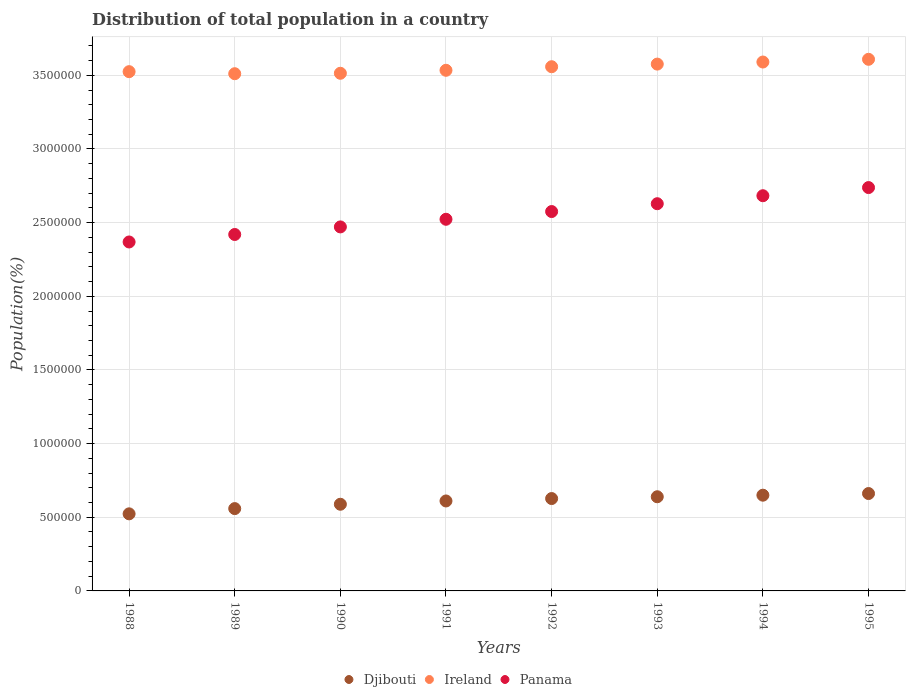How many different coloured dotlines are there?
Your response must be concise. 3. Is the number of dotlines equal to the number of legend labels?
Ensure brevity in your answer.  Yes. What is the population of in Panama in 1994?
Provide a short and direct response. 2.68e+06. Across all years, what is the maximum population of in Djibouti?
Provide a short and direct response. 6.61e+05. Across all years, what is the minimum population of in Djibouti?
Ensure brevity in your answer.  5.23e+05. What is the total population of in Panama in the graph?
Provide a succinct answer. 2.04e+07. What is the difference between the population of in Panama in 1989 and that in 1991?
Your response must be concise. -1.03e+05. What is the difference between the population of in Ireland in 1994 and the population of in Panama in 1992?
Provide a succinct answer. 1.02e+06. What is the average population of in Ireland per year?
Your answer should be compact. 3.55e+06. In the year 1993, what is the difference between the population of in Djibouti and population of in Ireland?
Make the answer very short. -2.94e+06. In how many years, is the population of in Panama greater than 1300000 %?
Make the answer very short. 8. What is the ratio of the population of in Panama in 1990 to that in 1993?
Offer a terse response. 0.94. What is the difference between the highest and the second highest population of in Ireland?
Your answer should be very brief. 1.85e+04. What is the difference between the highest and the lowest population of in Ireland?
Keep it short and to the point. 9.78e+04. In how many years, is the population of in Ireland greater than the average population of in Ireland taken over all years?
Your answer should be compact. 4. Does the population of in Djibouti monotonically increase over the years?
Make the answer very short. Yes. Is the population of in Ireland strictly greater than the population of in Panama over the years?
Provide a short and direct response. Yes. How many dotlines are there?
Your answer should be compact. 3. What is the difference between two consecutive major ticks on the Y-axis?
Ensure brevity in your answer.  5.00e+05. Are the values on the major ticks of Y-axis written in scientific E-notation?
Offer a very short reply. No. Does the graph contain any zero values?
Provide a succinct answer. No. How are the legend labels stacked?
Give a very brief answer. Horizontal. What is the title of the graph?
Give a very brief answer. Distribution of total population in a country. Does "Liechtenstein" appear as one of the legend labels in the graph?
Your response must be concise. No. What is the label or title of the X-axis?
Give a very brief answer. Years. What is the label or title of the Y-axis?
Keep it short and to the point. Population(%). What is the Population(%) of Djibouti in 1988?
Provide a succinct answer. 5.23e+05. What is the Population(%) of Ireland in 1988?
Provide a succinct answer. 3.52e+06. What is the Population(%) of Panama in 1988?
Your answer should be compact. 2.37e+06. What is the Population(%) in Djibouti in 1989?
Make the answer very short. 5.59e+05. What is the Population(%) in Ireland in 1989?
Give a very brief answer. 3.51e+06. What is the Population(%) of Panama in 1989?
Keep it short and to the point. 2.42e+06. What is the Population(%) of Djibouti in 1990?
Keep it short and to the point. 5.88e+05. What is the Population(%) in Ireland in 1990?
Ensure brevity in your answer.  3.51e+06. What is the Population(%) in Panama in 1990?
Give a very brief answer. 2.47e+06. What is the Population(%) of Djibouti in 1991?
Offer a terse response. 6.11e+05. What is the Population(%) of Ireland in 1991?
Your answer should be very brief. 3.53e+06. What is the Population(%) of Panama in 1991?
Your response must be concise. 2.52e+06. What is the Population(%) of Djibouti in 1992?
Provide a short and direct response. 6.27e+05. What is the Population(%) in Ireland in 1992?
Provide a short and direct response. 3.56e+06. What is the Population(%) in Panama in 1992?
Offer a very short reply. 2.58e+06. What is the Population(%) in Djibouti in 1993?
Keep it short and to the point. 6.39e+05. What is the Population(%) of Ireland in 1993?
Your answer should be compact. 3.58e+06. What is the Population(%) in Panama in 1993?
Make the answer very short. 2.63e+06. What is the Population(%) of Djibouti in 1994?
Offer a terse response. 6.50e+05. What is the Population(%) of Ireland in 1994?
Offer a terse response. 3.59e+06. What is the Population(%) of Panama in 1994?
Your response must be concise. 2.68e+06. What is the Population(%) of Djibouti in 1995?
Your response must be concise. 6.61e+05. What is the Population(%) of Ireland in 1995?
Provide a short and direct response. 3.61e+06. What is the Population(%) of Panama in 1995?
Keep it short and to the point. 2.74e+06. Across all years, what is the maximum Population(%) of Djibouti?
Your answer should be compact. 6.61e+05. Across all years, what is the maximum Population(%) of Ireland?
Offer a very short reply. 3.61e+06. Across all years, what is the maximum Population(%) of Panama?
Offer a very short reply. 2.74e+06. Across all years, what is the minimum Population(%) in Djibouti?
Provide a short and direct response. 5.23e+05. Across all years, what is the minimum Population(%) of Ireland?
Give a very brief answer. 3.51e+06. Across all years, what is the minimum Population(%) in Panama?
Provide a short and direct response. 2.37e+06. What is the total Population(%) in Djibouti in the graph?
Keep it short and to the point. 4.86e+06. What is the total Population(%) in Ireland in the graph?
Provide a short and direct response. 2.84e+07. What is the total Population(%) of Panama in the graph?
Keep it short and to the point. 2.04e+07. What is the difference between the Population(%) in Djibouti in 1988 and that in 1989?
Offer a terse response. -3.55e+04. What is the difference between the Population(%) in Ireland in 1988 and that in 1989?
Provide a short and direct response. 1.39e+04. What is the difference between the Population(%) in Panama in 1988 and that in 1989?
Your response must be concise. -5.08e+04. What is the difference between the Population(%) of Djibouti in 1988 and that in 1990?
Provide a succinct answer. -6.51e+04. What is the difference between the Population(%) in Ireland in 1988 and that in 1990?
Provide a short and direct response. 1.10e+04. What is the difference between the Population(%) of Panama in 1988 and that in 1990?
Offer a terse response. -1.02e+05. What is the difference between the Population(%) in Djibouti in 1988 and that in 1991?
Your answer should be very brief. -8.74e+04. What is the difference between the Population(%) in Ireland in 1988 and that in 1991?
Keep it short and to the point. -9286. What is the difference between the Population(%) in Panama in 1988 and that in 1991?
Your response must be concise. -1.54e+05. What is the difference between the Population(%) of Djibouti in 1988 and that in 1992?
Make the answer very short. -1.04e+05. What is the difference between the Population(%) of Ireland in 1988 and that in 1992?
Provide a succinct answer. -3.35e+04. What is the difference between the Population(%) of Panama in 1988 and that in 1992?
Keep it short and to the point. -2.07e+05. What is the difference between the Population(%) in Djibouti in 1988 and that in 1993?
Provide a succinct answer. -1.16e+05. What is the difference between the Population(%) in Ireland in 1988 and that in 1993?
Keep it short and to the point. -5.13e+04. What is the difference between the Population(%) of Panama in 1988 and that in 1993?
Ensure brevity in your answer.  -2.60e+05. What is the difference between the Population(%) in Djibouti in 1988 and that in 1994?
Offer a very short reply. -1.27e+05. What is the difference between the Population(%) of Ireland in 1988 and that in 1994?
Give a very brief answer. -6.54e+04. What is the difference between the Population(%) in Panama in 1988 and that in 1994?
Make the answer very short. -3.14e+05. What is the difference between the Population(%) of Djibouti in 1988 and that in 1995?
Provide a short and direct response. -1.38e+05. What is the difference between the Population(%) in Ireland in 1988 and that in 1995?
Your answer should be compact. -8.39e+04. What is the difference between the Population(%) in Panama in 1988 and that in 1995?
Your answer should be compact. -3.69e+05. What is the difference between the Population(%) of Djibouti in 1989 and that in 1990?
Offer a terse response. -2.95e+04. What is the difference between the Population(%) in Ireland in 1989 and that in 1990?
Give a very brief answer. -2965. What is the difference between the Population(%) in Panama in 1989 and that in 1990?
Keep it short and to the point. -5.14e+04. What is the difference between the Population(%) of Djibouti in 1989 and that in 1991?
Your response must be concise. -5.19e+04. What is the difference between the Population(%) in Ireland in 1989 and that in 1991?
Keep it short and to the point. -2.32e+04. What is the difference between the Population(%) of Panama in 1989 and that in 1991?
Offer a terse response. -1.03e+05. What is the difference between the Population(%) of Djibouti in 1989 and that in 1992?
Your response must be concise. -6.83e+04. What is the difference between the Population(%) of Ireland in 1989 and that in 1992?
Ensure brevity in your answer.  -4.74e+04. What is the difference between the Population(%) of Panama in 1989 and that in 1992?
Make the answer very short. -1.56e+05. What is the difference between the Population(%) of Djibouti in 1989 and that in 1993?
Your answer should be very brief. -8.04e+04. What is the difference between the Population(%) in Ireland in 1989 and that in 1993?
Offer a terse response. -6.53e+04. What is the difference between the Population(%) in Panama in 1989 and that in 1993?
Make the answer very short. -2.09e+05. What is the difference between the Population(%) of Djibouti in 1989 and that in 1994?
Make the answer very short. -9.11e+04. What is the difference between the Population(%) of Ireland in 1989 and that in 1994?
Offer a very short reply. -7.94e+04. What is the difference between the Population(%) of Panama in 1989 and that in 1994?
Ensure brevity in your answer.  -2.63e+05. What is the difference between the Population(%) of Djibouti in 1989 and that in 1995?
Your answer should be very brief. -1.02e+05. What is the difference between the Population(%) in Ireland in 1989 and that in 1995?
Offer a very short reply. -9.78e+04. What is the difference between the Population(%) in Panama in 1989 and that in 1995?
Your answer should be compact. -3.19e+05. What is the difference between the Population(%) of Djibouti in 1990 and that in 1991?
Make the answer very short. -2.23e+04. What is the difference between the Population(%) of Ireland in 1990 and that in 1991?
Your response must be concise. -2.03e+04. What is the difference between the Population(%) in Panama in 1990 and that in 1991?
Your answer should be compact. -5.19e+04. What is the difference between the Population(%) of Djibouti in 1990 and that in 1992?
Keep it short and to the point. -3.87e+04. What is the difference between the Population(%) of Ireland in 1990 and that in 1992?
Provide a short and direct response. -4.45e+04. What is the difference between the Population(%) of Panama in 1990 and that in 1992?
Provide a short and direct response. -1.04e+05. What is the difference between the Population(%) in Djibouti in 1990 and that in 1993?
Make the answer very short. -5.09e+04. What is the difference between the Population(%) of Ireland in 1990 and that in 1993?
Provide a short and direct response. -6.23e+04. What is the difference between the Population(%) in Panama in 1990 and that in 1993?
Provide a short and direct response. -1.58e+05. What is the difference between the Population(%) in Djibouti in 1990 and that in 1994?
Offer a terse response. -6.15e+04. What is the difference between the Population(%) in Ireland in 1990 and that in 1994?
Keep it short and to the point. -7.64e+04. What is the difference between the Population(%) of Panama in 1990 and that in 1994?
Your response must be concise. -2.12e+05. What is the difference between the Population(%) of Djibouti in 1990 and that in 1995?
Offer a terse response. -7.27e+04. What is the difference between the Population(%) in Ireland in 1990 and that in 1995?
Your answer should be compact. -9.49e+04. What is the difference between the Population(%) in Panama in 1990 and that in 1995?
Your response must be concise. -2.67e+05. What is the difference between the Population(%) in Djibouti in 1991 and that in 1992?
Provide a short and direct response. -1.64e+04. What is the difference between the Population(%) of Ireland in 1991 and that in 1992?
Give a very brief answer. -2.42e+04. What is the difference between the Population(%) in Panama in 1991 and that in 1992?
Provide a succinct answer. -5.24e+04. What is the difference between the Population(%) in Djibouti in 1991 and that in 1993?
Your answer should be compact. -2.85e+04. What is the difference between the Population(%) of Ireland in 1991 and that in 1993?
Ensure brevity in your answer.  -4.20e+04. What is the difference between the Population(%) in Panama in 1991 and that in 1993?
Provide a succinct answer. -1.06e+05. What is the difference between the Population(%) in Djibouti in 1991 and that in 1994?
Your answer should be very brief. -3.92e+04. What is the difference between the Population(%) of Ireland in 1991 and that in 1994?
Give a very brief answer. -5.62e+04. What is the difference between the Population(%) of Panama in 1991 and that in 1994?
Offer a very short reply. -1.60e+05. What is the difference between the Population(%) in Djibouti in 1991 and that in 1995?
Keep it short and to the point. -5.04e+04. What is the difference between the Population(%) of Ireland in 1991 and that in 1995?
Your answer should be very brief. -7.46e+04. What is the difference between the Population(%) in Panama in 1991 and that in 1995?
Offer a terse response. -2.15e+05. What is the difference between the Population(%) in Djibouti in 1992 and that in 1993?
Provide a short and direct response. -1.22e+04. What is the difference between the Population(%) of Ireland in 1992 and that in 1993?
Give a very brief answer. -1.78e+04. What is the difference between the Population(%) of Panama in 1992 and that in 1993?
Your answer should be very brief. -5.32e+04. What is the difference between the Population(%) of Djibouti in 1992 and that in 1994?
Your response must be concise. -2.28e+04. What is the difference between the Population(%) of Ireland in 1992 and that in 1994?
Offer a very short reply. -3.20e+04. What is the difference between the Population(%) of Panama in 1992 and that in 1994?
Give a very brief answer. -1.07e+05. What is the difference between the Population(%) in Djibouti in 1992 and that in 1995?
Keep it short and to the point. -3.40e+04. What is the difference between the Population(%) of Ireland in 1992 and that in 1995?
Your answer should be very brief. -5.04e+04. What is the difference between the Population(%) in Panama in 1992 and that in 1995?
Ensure brevity in your answer.  -1.63e+05. What is the difference between the Population(%) of Djibouti in 1993 and that in 1994?
Provide a succinct answer. -1.07e+04. What is the difference between the Population(%) of Ireland in 1993 and that in 1994?
Provide a succinct answer. -1.41e+04. What is the difference between the Population(%) of Panama in 1993 and that in 1994?
Your response must be concise. -5.42e+04. What is the difference between the Population(%) of Djibouti in 1993 and that in 1995?
Offer a terse response. -2.19e+04. What is the difference between the Population(%) of Ireland in 1993 and that in 1995?
Provide a short and direct response. -3.26e+04. What is the difference between the Population(%) of Panama in 1993 and that in 1995?
Your answer should be compact. -1.10e+05. What is the difference between the Population(%) of Djibouti in 1994 and that in 1995?
Make the answer very short. -1.12e+04. What is the difference between the Population(%) of Ireland in 1994 and that in 1995?
Offer a very short reply. -1.85e+04. What is the difference between the Population(%) in Panama in 1994 and that in 1995?
Give a very brief answer. -5.54e+04. What is the difference between the Population(%) in Djibouti in 1988 and the Population(%) in Ireland in 1989?
Your response must be concise. -2.99e+06. What is the difference between the Population(%) in Djibouti in 1988 and the Population(%) in Panama in 1989?
Your response must be concise. -1.90e+06. What is the difference between the Population(%) of Ireland in 1988 and the Population(%) of Panama in 1989?
Give a very brief answer. 1.11e+06. What is the difference between the Population(%) of Djibouti in 1988 and the Population(%) of Ireland in 1990?
Give a very brief answer. -2.99e+06. What is the difference between the Population(%) in Djibouti in 1988 and the Population(%) in Panama in 1990?
Your response must be concise. -1.95e+06. What is the difference between the Population(%) of Ireland in 1988 and the Population(%) of Panama in 1990?
Provide a succinct answer. 1.05e+06. What is the difference between the Population(%) of Djibouti in 1988 and the Population(%) of Ireland in 1991?
Your response must be concise. -3.01e+06. What is the difference between the Population(%) of Djibouti in 1988 and the Population(%) of Panama in 1991?
Keep it short and to the point. -2.00e+06. What is the difference between the Population(%) of Ireland in 1988 and the Population(%) of Panama in 1991?
Provide a succinct answer. 1.00e+06. What is the difference between the Population(%) in Djibouti in 1988 and the Population(%) in Ireland in 1992?
Keep it short and to the point. -3.04e+06. What is the difference between the Population(%) in Djibouti in 1988 and the Population(%) in Panama in 1992?
Your answer should be very brief. -2.05e+06. What is the difference between the Population(%) of Ireland in 1988 and the Population(%) of Panama in 1992?
Your response must be concise. 9.50e+05. What is the difference between the Population(%) of Djibouti in 1988 and the Population(%) of Ireland in 1993?
Provide a succinct answer. -3.05e+06. What is the difference between the Population(%) of Djibouti in 1988 and the Population(%) of Panama in 1993?
Provide a short and direct response. -2.11e+06. What is the difference between the Population(%) in Ireland in 1988 and the Population(%) in Panama in 1993?
Offer a very short reply. 8.96e+05. What is the difference between the Population(%) of Djibouti in 1988 and the Population(%) of Ireland in 1994?
Provide a succinct answer. -3.07e+06. What is the difference between the Population(%) in Djibouti in 1988 and the Population(%) in Panama in 1994?
Provide a succinct answer. -2.16e+06. What is the difference between the Population(%) in Ireland in 1988 and the Population(%) in Panama in 1994?
Make the answer very short. 8.42e+05. What is the difference between the Population(%) in Djibouti in 1988 and the Population(%) in Ireland in 1995?
Your answer should be very brief. -3.09e+06. What is the difference between the Population(%) of Djibouti in 1988 and the Population(%) of Panama in 1995?
Make the answer very short. -2.21e+06. What is the difference between the Population(%) of Ireland in 1988 and the Population(%) of Panama in 1995?
Your response must be concise. 7.87e+05. What is the difference between the Population(%) of Djibouti in 1989 and the Population(%) of Ireland in 1990?
Provide a short and direct response. -2.96e+06. What is the difference between the Population(%) in Djibouti in 1989 and the Population(%) in Panama in 1990?
Make the answer very short. -1.91e+06. What is the difference between the Population(%) in Ireland in 1989 and the Population(%) in Panama in 1990?
Offer a terse response. 1.04e+06. What is the difference between the Population(%) of Djibouti in 1989 and the Population(%) of Ireland in 1991?
Provide a succinct answer. -2.98e+06. What is the difference between the Population(%) of Djibouti in 1989 and the Population(%) of Panama in 1991?
Your answer should be very brief. -1.96e+06. What is the difference between the Population(%) in Ireland in 1989 and the Population(%) in Panama in 1991?
Give a very brief answer. 9.88e+05. What is the difference between the Population(%) in Djibouti in 1989 and the Population(%) in Ireland in 1992?
Your response must be concise. -3.00e+06. What is the difference between the Population(%) in Djibouti in 1989 and the Population(%) in Panama in 1992?
Provide a short and direct response. -2.02e+06. What is the difference between the Population(%) of Ireland in 1989 and the Population(%) of Panama in 1992?
Give a very brief answer. 9.36e+05. What is the difference between the Population(%) in Djibouti in 1989 and the Population(%) in Ireland in 1993?
Your answer should be very brief. -3.02e+06. What is the difference between the Population(%) in Djibouti in 1989 and the Population(%) in Panama in 1993?
Provide a short and direct response. -2.07e+06. What is the difference between the Population(%) of Ireland in 1989 and the Population(%) of Panama in 1993?
Keep it short and to the point. 8.82e+05. What is the difference between the Population(%) of Djibouti in 1989 and the Population(%) of Ireland in 1994?
Offer a very short reply. -3.03e+06. What is the difference between the Population(%) in Djibouti in 1989 and the Population(%) in Panama in 1994?
Give a very brief answer. -2.12e+06. What is the difference between the Population(%) in Ireland in 1989 and the Population(%) in Panama in 1994?
Make the answer very short. 8.28e+05. What is the difference between the Population(%) of Djibouti in 1989 and the Population(%) of Ireland in 1995?
Provide a succinct answer. -3.05e+06. What is the difference between the Population(%) of Djibouti in 1989 and the Population(%) of Panama in 1995?
Provide a short and direct response. -2.18e+06. What is the difference between the Population(%) of Ireland in 1989 and the Population(%) of Panama in 1995?
Keep it short and to the point. 7.73e+05. What is the difference between the Population(%) in Djibouti in 1990 and the Population(%) in Ireland in 1991?
Your response must be concise. -2.95e+06. What is the difference between the Population(%) in Djibouti in 1990 and the Population(%) in Panama in 1991?
Your answer should be very brief. -1.93e+06. What is the difference between the Population(%) of Ireland in 1990 and the Population(%) of Panama in 1991?
Your response must be concise. 9.91e+05. What is the difference between the Population(%) in Djibouti in 1990 and the Population(%) in Ireland in 1992?
Give a very brief answer. -2.97e+06. What is the difference between the Population(%) in Djibouti in 1990 and the Population(%) in Panama in 1992?
Ensure brevity in your answer.  -1.99e+06. What is the difference between the Population(%) of Ireland in 1990 and the Population(%) of Panama in 1992?
Make the answer very short. 9.39e+05. What is the difference between the Population(%) in Djibouti in 1990 and the Population(%) in Ireland in 1993?
Give a very brief answer. -2.99e+06. What is the difference between the Population(%) of Djibouti in 1990 and the Population(%) of Panama in 1993?
Give a very brief answer. -2.04e+06. What is the difference between the Population(%) of Ireland in 1990 and the Population(%) of Panama in 1993?
Keep it short and to the point. 8.85e+05. What is the difference between the Population(%) in Djibouti in 1990 and the Population(%) in Ireland in 1994?
Offer a terse response. -3.00e+06. What is the difference between the Population(%) of Djibouti in 1990 and the Population(%) of Panama in 1994?
Your answer should be compact. -2.09e+06. What is the difference between the Population(%) of Ireland in 1990 and the Population(%) of Panama in 1994?
Give a very brief answer. 8.31e+05. What is the difference between the Population(%) of Djibouti in 1990 and the Population(%) of Ireland in 1995?
Offer a very short reply. -3.02e+06. What is the difference between the Population(%) in Djibouti in 1990 and the Population(%) in Panama in 1995?
Keep it short and to the point. -2.15e+06. What is the difference between the Population(%) of Ireland in 1990 and the Population(%) of Panama in 1995?
Ensure brevity in your answer.  7.76e+05. What is the difference between the Population(%) in Djibouti in 1991 and the Population(%) in Ireland in 1992?
Make the answer very short. -2.95e+06. What is the difference between the Population(%) in Djibouti in 1991 and the Population(%) in Panama in 1992?
Make the answer very short. -1.96e+06. What is the difference between the Population(%) of Ireland in 1991 and the Population(%) of Panama in 1992?
Your response must be concise. 9.59e+05. What is the difference between the Population(%) in Djibouti in 1991 and the Population(%) in Ireland in 1993?
Offer a very short reply. -2.97e+06. What is the difference between the Population(%) of Djibouti in 1991 and the Population(%) of Panama in 1993?
Ensure brevity in your answer.  -2.02e+06. What is the difference between the Population(%) of Ireland in 1991 and the Population(%) of Panama in 1993?
Your answer should be very brief. 9.06e+05. What is the difference between the Population(%) of Djibouti in 1991 and the Population(%) of Ireland in 1994?
Offer a terse response. -2.98e+06. What is the difference between the Population(%) in Djibouti in 1991 and the Population(%) in Panama in 1994?
Make the answer very short. -2.07e+06. What is the difference between the Population(%) in Ireland in 1991 and the Population(%) in Panama in 1994?
Offer a very short reply. 8.52e+05. What is the difference between the Population(%) of Djibouti in 1991 and the Population(%) of Ireland in 1995?
Ensure brevity in your answer.  -3.00e+06. What is the difference between the Population(%) of Djibouti in 1991 and the Population(%) of Panama in 1995?
Offer a very short reply. -2.13e+06. What is the difference between the Population(%) of Ireland in 1991 and the Population(%) of Panama in 1995?
Your answer should be compact. 7.96e+05. What is the difference between the Population(%) of Djibouti in 1992 and the Population(%) of Ireland in 1993?
Ensure brevity in your answer.  -2.95e+06. What is the difference between the Population(%) of Djibouti in 1992 and the Population(%) of Panama in 1993?
Provide a short and direct response. -2.00e+06. What is the difference between the Population(%) of Ireland in 1992 and the Population(%) of Panama in 1993?
Make the answer very short. 9.30e+05. What is the difference between the Population(%) of Djibouti in 1992 and the Population(%) of Ireland in 1994?
Your answer should be very brief. -2.96e+06. What is the difference between the Population(%) in Djibouti in 1992 and the Population(%) in Panama in 1994?
Provide a succinct answer. -2.06e+06. What is the difference between the Population(%) in Ireland in 1992 and the Population(%) in Panama in 1994?
Make the answer very short. 8.76e+05. What is the difference between the Population(%) in Djibouti in 1992 and the Population(%) in Ireland in 1995?
Keep it short and to the point. -2.98e+06. What is the difference between the Population(%) in Djibouti in 1992 and the Population(%) in Panama in 1995?
Provide a short and direct response. -2.11e+06. What is the difference between the Population(%) in Ireland in 1992 and the Population(%) in Panama in 1995?
Your response must be concise. 8.20e+05. What is the difference between the Population(%) in Djibouti in 1993 and the Population(%) in Ireland in 1994?
Your response must be concise. -2.95e+06. What is the difference between the Population(%) in Djibouti in 1993 and the Population(%) in Panama in 1994?
Your answer should be very brief. -2.04e+06. What is the difference between the Population(%) in Ireland in 1993 and the Population(%) in Panama in 1994?
Your answer should be very brief. 8.94e+05. What is the difference between the Population(%) of Djibouti in 1993 and the Population(%) of Ireland in 1995?
Keep it short and to the point. -2.97e+06. What is the difference between the Population(%) in Djibouti in 1993 and the Population(%) in Panama in 1995?
Provide a succinct answer. -2.10e+06. What is the difference between the Population(%) of Ireland in 1993 and the Population(%) of Panama in 1995?
Provide a short and direct response. 8.38e+05. What is the difference between the Population(%) of Djibouti in 1994 and the Population(%) of Ireland in 1995?
Your answer should be very brief. -2.96e+06. What is the difference between the Population(%) in Djibouti in 1994 and the Population(%) in Panama in 1995?
Offer a terse response. -2.09e+06. What is the difference between the Population(%) of Ireland in 1994 and the Population(%) of Panama in 1995?
Your response must be concise. 8.52e+05. What is the average Population(%) of Djibouti per year?
Your answer should be compact. 6.07e+05. What is the average Population(%) in Ireland per year?
Your response must be concise. 3.55e+06. What is the average Population(%) of Panama per year?
Provide a short and direct response. 2.55e+06. In the year 1988, what is the difference between the Population(%) of Djibouti and Population(%) of Ireland?
Make the answer very short. -3.00e+06. In the year 1988, what is the difference between the Population(%) of Djibouti and Population(%) of Panama?
Provide a succinct answer. -1.85e+06. In the year 1988, what is the difference between the Population(%) in Ireland and Population(%) in Panama?
Offer a terse response. 1.16e+06. In the year 1989, what is the difference between the Population(%) in Djibouti and Population(%) in Ireland?
Give a very brief answer. -2.95e+06. In the year 1989, what is the difference between the Population(%) in Djibouti and Population(%) in Panama?
Give a very brief answer. -1.86e+06. In the year 1989, what is the difference between the Population(%) of Ireland and Population(%) of Panama?
Make the answer very short. 1.09e+06. In the year 1990, what is the difference between the Population(%) of Djibouti and Population(%) of Ireland?
Your answer should be very brief. -2.93e+06. In the year 1990, what is the difference between the Population(%) in Djibouti and Population(%) in Panama?
Give a very brief answer. -1.88e+06. In the year 1990, what is the difference between the Population(%) of Ireland and Population(%) of Panama?
Provide a short and direct response. 1.04e+06. In the year 1991, what is the difference between the Population(%) in Djibouti and Population(%) in Ireland?
Offer a terse response. -2.92e+06. In the year 1991, what is the difference between the Population(%) of Djibouti and Population(%) of Panama?
Your answer should be compact. -1.91e+06. In the year 1991, what is the difference between the Population(%) in Ireland and Population(%) in Panama?
Offer a very short reply. 1.01e+06. In the year 1992, what is the difference between the Population(%) in Djibouti and Population(%) in Ireland?
Give a very brief answer. -2.93e+06. In the year 1992, what is the difference between the Population(%) in Djibouti and Population(%) in Panama?
Your answer should be compact. -1.95e+06. In the year 1992, what is the difference between the Population(%) in Ireland and Population(%) in Panama?
Offer a very short reply. 9.83e+05. In the year 1993, what is the difference between the Population(%) in Djibouti and Population(%) in Ireland?
Your answer should be very brief. -2.94e+06. In the year 1993, what is the difference between the Population(%) in Djibouti and Population(%) in Panama?
Offer a terse response. -1.99e+06. In the year 1993, what is the difference between the Population(%) in Ireland and Population(%) in Panama?
Provide a short and direct response. 9.48e+05. In the year 1994, what is the difference between the Population(%) in Djibouti and Population(%) in Ireland?
Ensure brevity in your answer.  -2.94e+06. In the year 1994, what is the difference between the Population(%) in Djibouti and Population(%) in Panama?
Your answer should be very brief. -2.03e+06. In the year 1994, what is the difference between the Population(%) in Ireland and Population(%) in Panama?
Ensure brevity in your answer.  9.08e+05. In the year 1995, what is the difference between the Population(%) in Djibouti and Population(%) in Ireland?
Your response must be concise. -2.95e+06. In the year 1995, what is the difference between the Population(%) of Djibouti and Population(%) of Panama?
Offer a very short reply. -2.08e+06. In the year 1995, what is the difference between the Population(%) of Ireland and Population(%) of Panama?
Provide a short and direct response. 8.71e+05. What is the ratio of the Population(%) in Djibouti in 1988 to that in 1989?
Provide a short and direct response. 0.94. What is the ratio of the Population(%) of Djibouti in 1988 to that in 1990?
Keep it short and to the point. 0.89. What is the ratio of the Population(%) of Panama in 1988 to that in 1990?
Provide a short and direct response. 0.96. What is the ratio of the Population(%) of Djibouti in 1988 to that in 1991?
Your answer should be very brief. 0.86. What is the ratio of the Population(%) in Ireland in 1988 to that in 1991?
Provide a short and direct response. 1. What is the ratio of the Population(%) in Panama in 1988 to that in 1991?
Provide a short and direct response. 0.94. What is the ratio of the Population(%) of Djibouti in 1988 to that in 1992?
Provide a succinct answer. 0.83. What is the ratio of the Population(%) in Ireland in 1988 to that in 1992?
Your response must be concise. 0.99. What is the ratio of the Population(%) of Panama in 1988 to that in 1992?
Make the answer very short. 0.92. What is the ratio of the Population(%) in Djibouti in 1988 to that in 1993?
Ensure brevity in your answer.  0.82. What is the ratio of the Population(%) of Ireland in 1988 to that in 1993?
Your answer should be compact. 0.99. What is the ratio of the Population(%) of Panama in 1988 to that in 1993?
Give a very brief answer. 0.9. What is the ratio of the Population(%) in Djibouti in 1988 to that in 1994?
Provide a short and direct response. 0.81. What is the ratio of the Population(%) of Ireland in 1988 to that in 1994?
Offer a terse response. 0.98. What is the ratio of the Population(%) in Panama in 1988 to that in 1994?
Give a very brief answer. 0.88. What is the ratio of the Population(%) of Djibouti in 1988 to that in 1995?
Provide a succinct answer. 0.79. What is the ratio of the Population(%) in Ireland in 1988 to that in 1995?
Your answer should be compact. 0.98. What is the ratio of the Population(%) of Panama in 1988 to that in 1995?
Make the answer very short. 0.87. What is the ratio of the Population(%) in Djibouti in 1989 to that in 1990?
Provide a succinct answer. 0.95. What is the ratio of the Population(%) in Panama in 1989 to that in 1990?
Provide a short and direct response. 0.98. What is the ratio of the Population(%) in Djibouti in 1989 to that in 1991?
Keep it short and to the point. 0.92. What is the ratio of the Population(%) of Ireland in 1989 to that in 1991?
Provide a short and direct response. 0.99. What is the ratio of the Population(%) in Panama in 1989 to that in 1991?
Offer a very short reply. 0.96. What is the ratio of the Population(%) of Djibouti in 1989 to that in 1992?
Make the answer very short. 0.89. What is the ratio of the Population(%) of Ireland in 1989 to that in 1992?
Offer a terse response. 0.99. What is the ratio of the Population(%) in Panama in 1989 to that in 1992?
Give a very brief answer. 0.94. What is the ratio of the Population(%) of Djibouti in 1989 to that in 1993?
Offer a very short reply. 0.87. What is the ratio of the Population(%) of Ireland in 1989 to that in 1993?
Make the answer very short. 0.98. What is the ratio of the Population(%) of Panama in 1989 to that in 1993?
Your answer should be compact. 0.92. What is the ratio of the Population(%) in Djibouti in 1989 to that in 1994?
Give a very brief answer. 0.86. What is the ratio of the Population(%) in Ireland in 1989 to that in 1994?
Offer a very short reply. 0.98. What is the ratio of the Population(%) of Panama in 1989 to that in 1994?
Your answer should be very brief. 0.9. What is the ratio of the Population(%) in Djibouti in 1989 to that in 1995?
Provide a succinct answer. 0.85. What is the ratio of the Population(%) in Ireland in 1989 to that in 1995?
Provide a succinct answer. 0.97. What is the ratio of the Population(%) of Panama in 1989 to that in 1995?
Offer a terse response. 0.88. What is the ratio of the Population(%) in Djibouti in 1990 to that in 1991?
Keep it short and to the point. 0.96. What is the ratio of the Population(%) of Ireland in 1990 to that in 1991?
Offer a terse response. 0.99. What is the ratio of the Population(%) of Panama in 1990 to that in 1991?
Your answer should be very brief. 0.98. What is the ratio of the Population(%) of Djibouti in 1990 to that in 1992?
Provide a succinct answer. 0.94. What is the ratio of the Population(%) in Ireland in 1990 to that in 1992?
Your answer should be compact. 0.99. What is the ratio of the Population(%) of Panama in 1990 to that in 1992?
Offer a very short reply. 0.96. What is the ratio of the Population(%) in Djibouti in 1990 to that in 1993?
Your response must be concise. 0.92. What is the ratio of the Population(%) of Ireland in 1990 to that in 1993?
Your answer should be very brief. 0.98. What is the ratio of the Population(%) in Panama in 1990 to that in 1993?
Make the answer very short. 0.94. What is the ratio of the Population(%) in Djibouti in 1990 to that in 1994?
Ensure brevity in your answer.  0.91. What is the ratio of the Population(%) of Ireland in 1990 to that in 1994?
Provide a succinct answer. 0.98. What is the ratio of the Population(%) of Panama in 1990 to that in 1994?
Offer a terse response. 0.92. What is the ratio of the Population(%) in Djibouti in 1990 to that in 1995?
Make the answer very short. 0.89. What is the ratio of the Population(%) of Ireland in 1990 to that in 1995?
Offer a very short reply. 0.97. What is the ratio of the Population(%) of Panama in 1990 to that in 1995?
Provide a succinct answer. 0.9. What is the ratio of the Population(%) of Djibouti in 1991 to that in 1992?
Provide a short and direct response. 0.97. What is the ratio of the Population(%) of Panama in 1991 to that in 1992?
Keep it short and to the point. 0.98. What is the ratio of the Population(%) of Djibouti in 1991 to that in 1993?
Give a very brief answer. 0.96. What is the ratio of the Population(%) of Ireland in 1991 to that in 1993?
Your response must be concise. 0.99. What is the ratio of the Population(%) of Panama in 1991 to that in 1993?
Your answer should be compact. 0.96. What is the ratio of the Population(%) of Djibouti in 1991 to that in 1994?
Keep it short and to the point. 0.94. What is the ratio of the Population(%) of Ireland in 1991 to that in 1994?
Give a very brief answer. 0.98. What is the ratio of the Population(%) of Panama in 1991 to that in 1994?
Ensure brevity in your answer.  0.94. What is the ratio of the Population(%) in Djibouti in 1991 to that in 1995?
Offer a terse response. 0.92. What is the ratio of the Population(%) in Ireland in 1991 to that in 1995?
Make the answer very short. 0.98. What is the ratio of the Population(%) of Panama in 1991 to that in 1995?
Your response must be concise. 0.92. What is the ratio of the Population(%) of Djibouti in 1992 to that in 1993?
Offer a terse response. 0.98. What is the ratio of the Population(%) in Ireland in 1992 to that in 1993?
Ensure brevity in your answer.  0.99. What is the ratio of the Population(%) in Panama in 1992 to that in 1993?
Your answer should be compact. 0.98. What is the ratio of the Population(%) in Djibouti in 1992 to that in 1994?
Provide a succinct answer. 0.96. What is the ratio of the Population(%) in Djibouti in 1992 to that in 1995?
Your answer should be compact. 0.95. What is the ratio of the Population(%) of Ireland in 1992 to that in 1995?
Your response must be concise. 0.99. What is the ratio of the Population(%) in Panama in 1992 to that in 1995?
Give a very brief answer. 0.94. What is the ratio of the Population(%) in Djibouti in 1993 to that in 1994?
Offer a terse response. 0.98. What is the ratio of the Population(%) of Panama in 1993 to that in 1994?
Your answer should be compact. 0.98. What is the ratio of the Population(%) in Djibouti in 1993 to that in 1995?
Make the answer very short. 0.97. What is the ratio of the Population(%) in Djibouti in 1994 to that in 1995?
Your answer should be very brief. 0.98. What is the ratio of the Population(%) of Panama in 1994 to that in 1995?
Make the answer very short. 0.98. What is the difference between the highest and the second highest Population(%) in Djibouti?
Offer a very short reply. 1.12e+04. What is the difference between the highest and the second highest Population(%) in Ireland?
Provide a short and direct response. 1.85e+04. What is the difference between the highest and the second highest Population(%) of Panama?
Keep it short and to the point. 5.54e+04. What is the difference between the highest and the lowest Population(%) of Djibouti?
Make the answer very short. 1.38e+05. What is the difference between the highest and the lowest Population(%) in Ireland?
Provide a succinct answer. 9.78e+04. What is the difference between the highest and the lowest Population(%) in Panama?
Your response must be concise. 3.69e+05. 